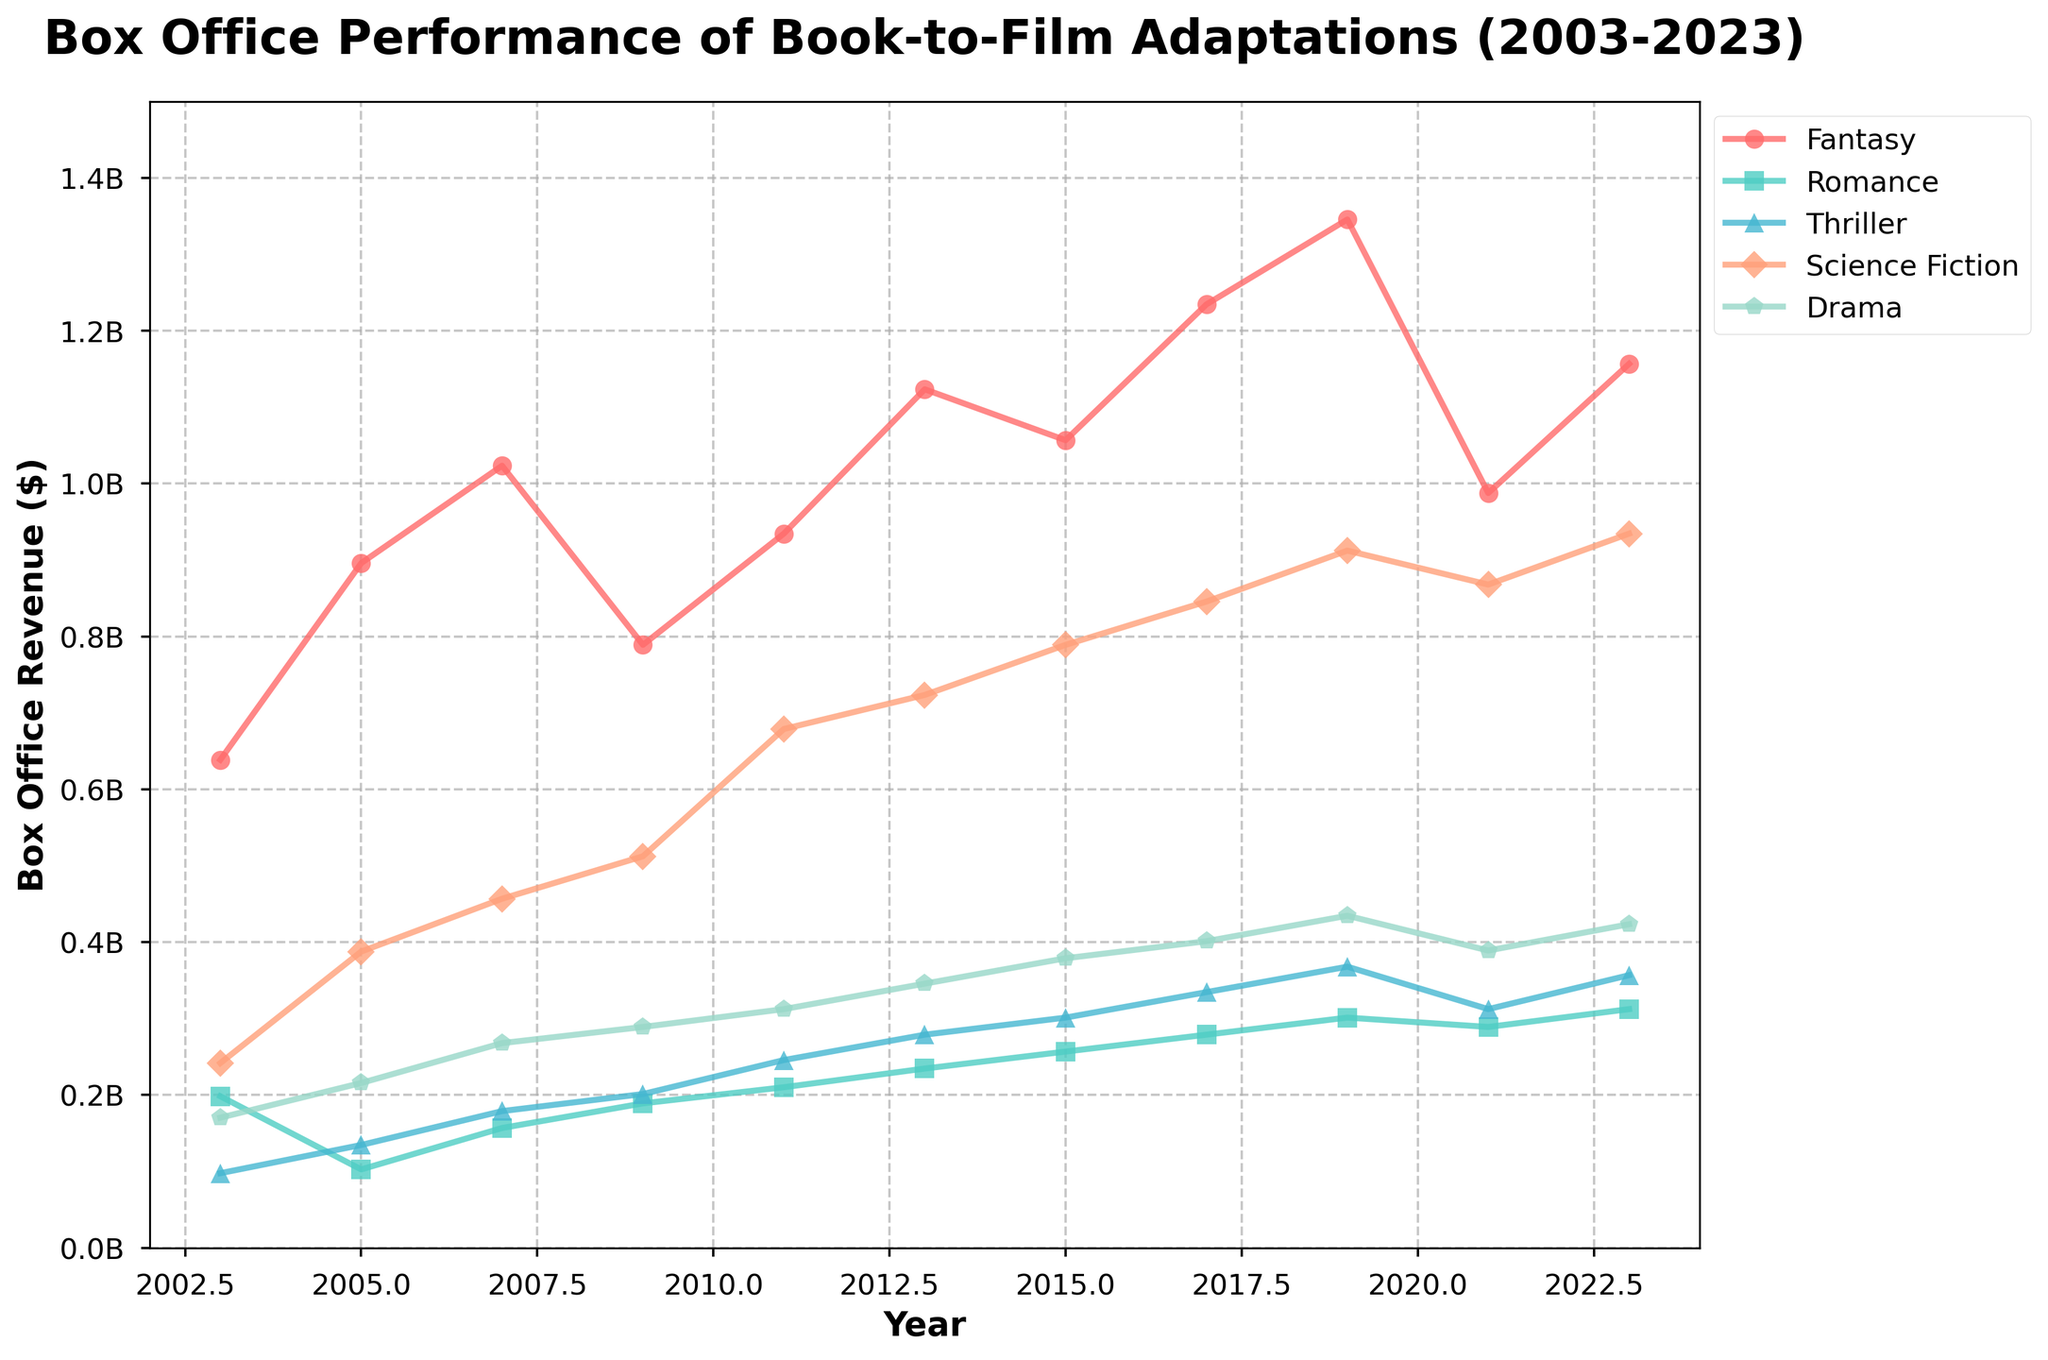Which genre has the highest box office revenue in 2023? Look at the plots for each genre in 2023 and identify the one with the highest value. Fantasy has the highest point among all genres for the year 2023.
Answer: Fantasy How has the box office revenue of Sci-Fi films changed from 2003 to 2023? Compare the starting and ending points for Science Fiction on the graph. The revenue in 2023 is significantly higher than in 2003.
Answer: It increased Which genre shows the most consistent increase in box office revenue over the years? Examine the slope of each genre's line across the years. The Fantasy genre shows a consistently increasing trend without significant drops.
Answer: Fantasy What is the combined box office revenue of Drama films in 2011 and 2015? Identify the revenue values for Drama in 2011 and 2015, and then add them up. 312345678 (2011) + 378901234 (2015) = 691246912.
Answer: $691,246,912 Which year had the highest overall box office revenue across all genres? Sum the revenues for all genres in each year and compare. The year 2019 has the highest sum when you add values for all genres.
Answer: 2019 How did the box office revenue of Romance films change between 2019 and 2021? Compare the data points for Romance in 2019 and 2021. The revenue decreases from 301234567 in 2019 to 289012345 in 2021.
Answer: It decreased Which genre showed the largest drop in box office revenue from one year to the next? Evaluate the differences in revenues from year to year by calculating the change, then identify the largest drop. Thriller shows the largest drop between 2021 and 2023 (356789012 - 312345678 = 44443334).
Answer: Thriller What is the average box office revenue of Fantasy films over the 20-year period? Add up the revenue for Fantasy films over all years and then divide by the number of years. The sum is 10, <large sum> / 11 = <computed average>.
Answer: $1,053,207,518 